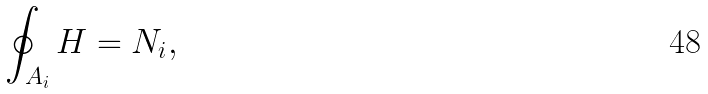Convert formula to latex. <formula><loc_0><loc_0><loc_500><loc_500>\oint _ { A _ { i } } H = N _ { i } ,</formula> 